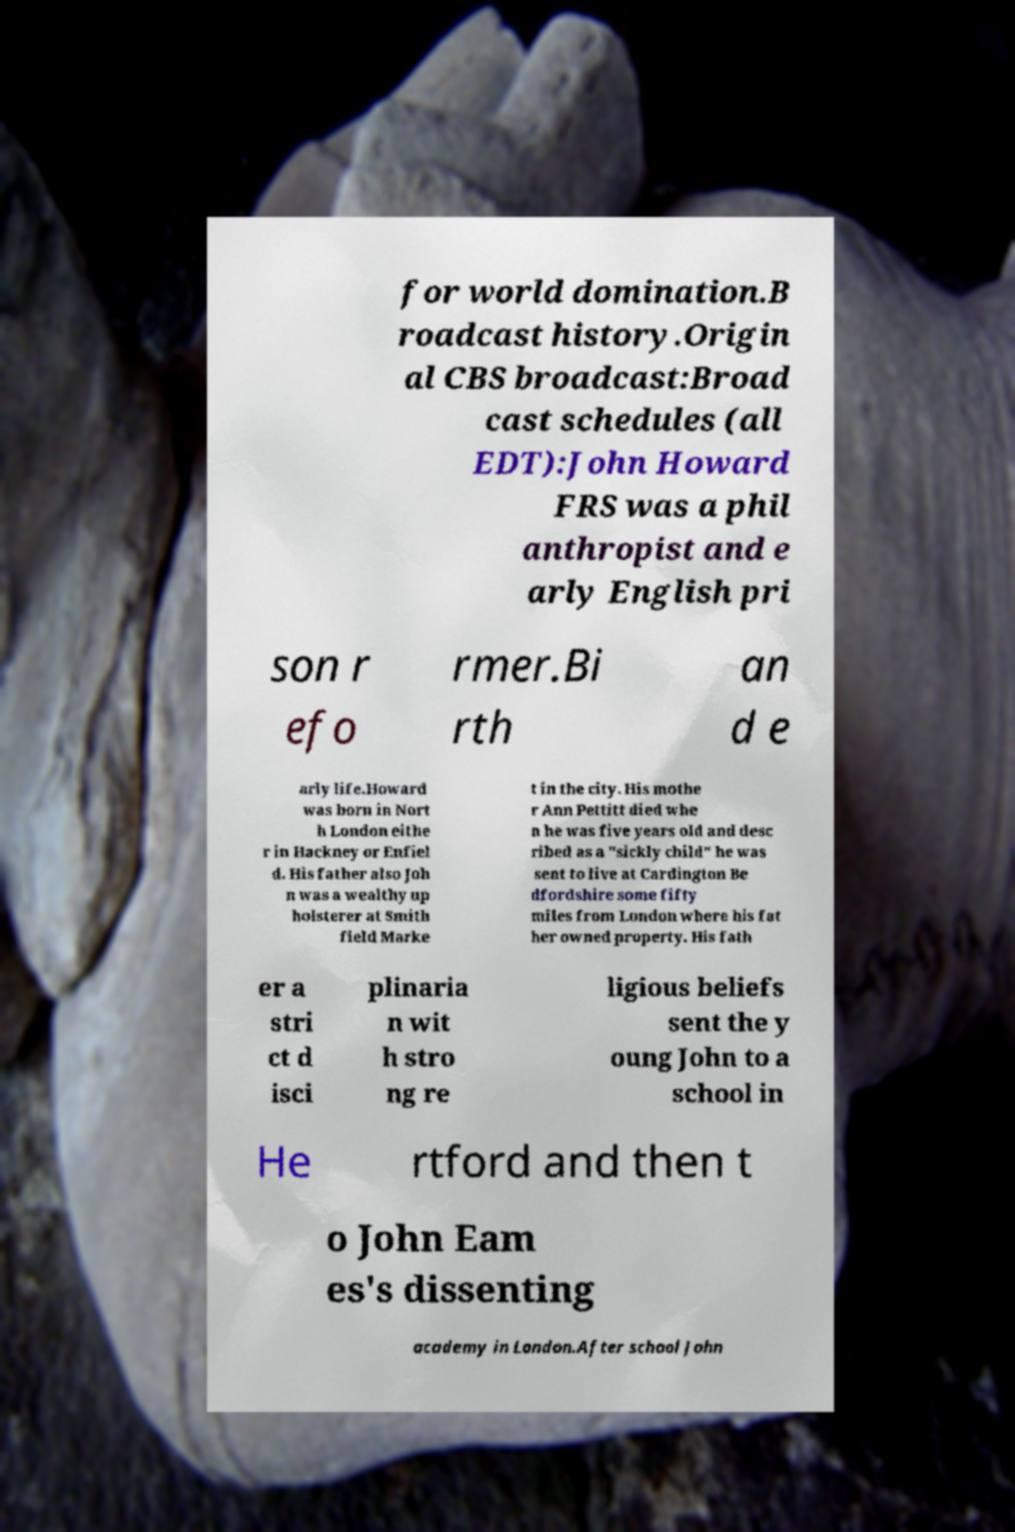For documentation purposes, I need the text within this image transcribed. Could you provide that? for world domination.B roadcast history.Origin al CBS broadcast:Broad cast schedules (all EDT):John Howard FRS was a phil anthropist and e arly English pri son r efo rmer.Bi rth an d e arly life.Howard was born in Nort h London eithe r in Hackney or Enfiel d. His father also Joh n was a wealthy up holsterer at Smith field Marke t in the city. His mothe r Ann Pettitt died whe n he was five years old and desc ribed as a "sickly child" he was sent to live at Cardington Be dfordshire some fifty miles from London where his fat her owned property. His fath er a stri ct d isci plinaria n wit h stro ng re ligious beliefs sent the y oung John to a school in He rtford and then t o John Eam es's dissenting academy in London.After school John 